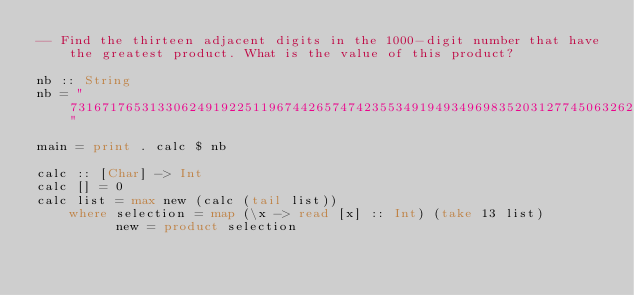<code> <loc_0><loc_0><loc_500><loc_500><_Haskell_>-- Find the thirteen adjacent digits in the 1000-digit number that have the greatest product. What is the value of this product?

nb :: String
nb = "7316717653133062491922511967442657474235534919493496983520312774506326239578318016984801869478851843858615607891129494954595017379583319528532088055111254069874715852386305071569329096329522744304355766896648950445244523161731856403098711121722383113622298934233803081353362766142828064444866452387493035890729629049156044077239071381051585930796086670172427121883998797908792274921901699720888093776657273330010533678812202354218097512545405947522435258490771167055601360483958644670632441572215539753697817977846174064955149290862569321978468622482839722413756570560574902614079729686524145351004748216637048440319989000889524345065854122758866688116427171479924442928230863465674813919123162824586178664583591245665294765456828489128831426076900422421902267105562632111110937054421750694165896040807198403850962455444362981230987879927244284909188845801561660979191338754992005240636899125607176060588611646710940507754100225698315520005593572972571636269561882670428252483600823257530420752963450"

main = print . calc $ nb

calc :: [Char] -> Int
calc [] = 0
calc list = max new (calc (tail list))
    where selection = map (\x -> read [x] :: Int) (take 13 list)
          new = product selection 
</code> 